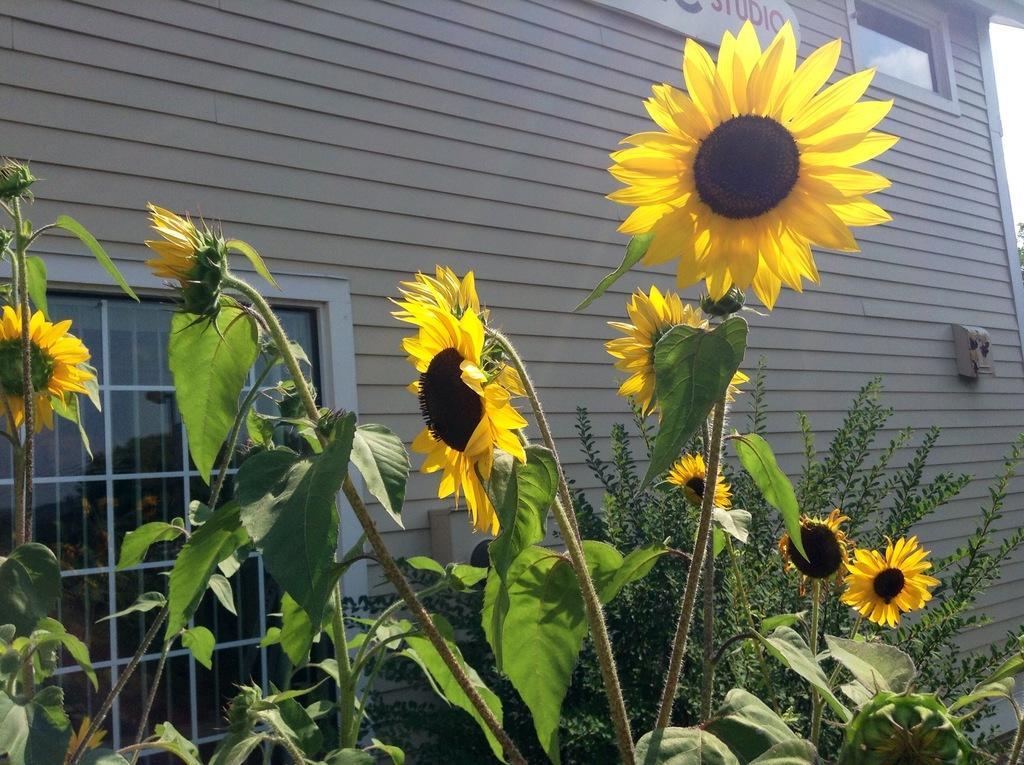Could you give a brief overview of what you see in this image? In the given image i can see a plants,flowers,window,ventilation and building with some text. 